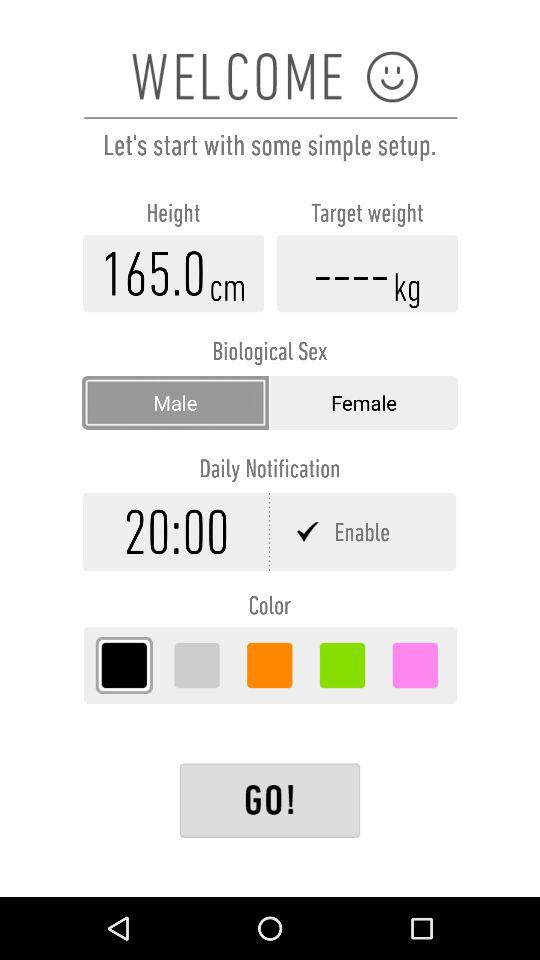What is the gender? The gender is male. 